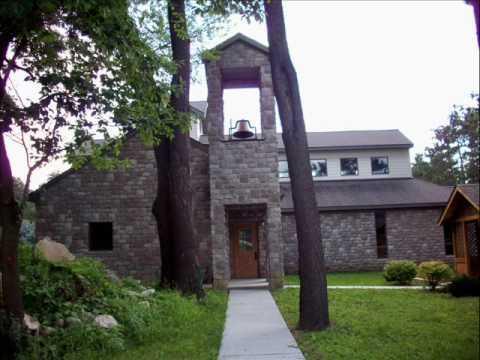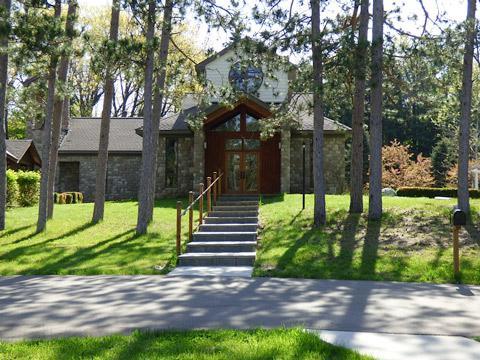The first image is the image on the left, the second image is the image on the right. For the images displayed, is the sentence "A bell tower is visible in at least one image." factually correct? Answer yes or no. Yes. 